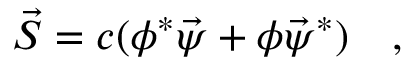<formula> <loc_0><loc_0><loc_500><loc_500>\vec { S } = c ( \phi ^ { * } \vec { \psi } + \phi \vec { \psi } ^ { * } ) \quad ,</formula> 